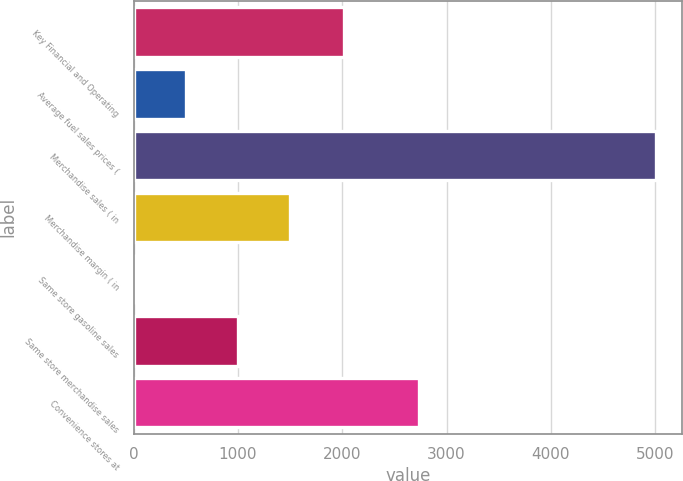<chart> <loc_0><loc_0><loc_500><loc_500><bar_chart><fcel>Key Financial and Operating<fcel>Average fuel sales prices (<fcel>Merchandise sales ( in<fcel>Merchandise margin ( in<fcel>Same store gasoline sales<fcel>Same store merchandise sales<fcel>Convenience stores at<nl><fcel>2016<fcel>501.06<fcel>5007<fcel>1502.38<fcel>0.4<fcel>1001.72<fcel>2733<nl></chart> 